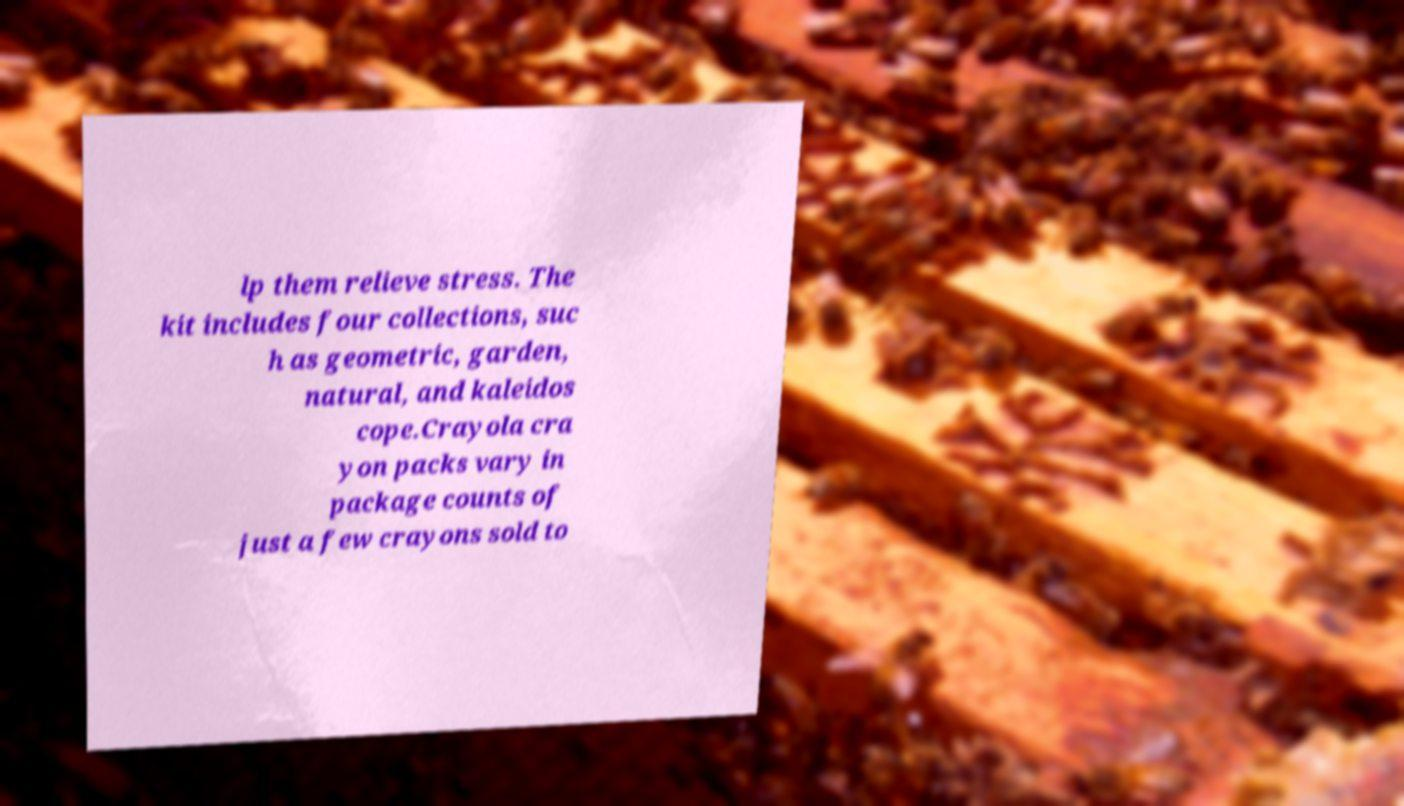Can you read and provide the text displayed in the image?This photo seems to have some interesting text. Can you extract and type it out for me? lp them relieve stress. The kit includes four collections, suc h as geometric, garden, natural, and kaleidos cope.Crayola cra yon packs vary in package counts of just a few crayons sold to 